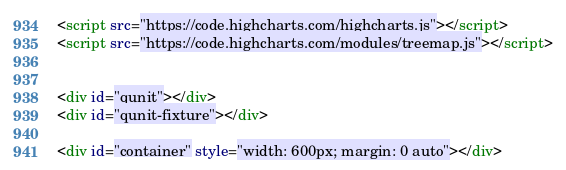<code> <loc_0><loc_0><loc_500><loc_500><_HTML_><script src="https://code.highcharts.com/highcharts.js"></script>
<script src="https://code.highcharts.com/modules/treemap.js"></script>


<div id="qunit"></div>
<div id="qunit-fixture"></div>

<div id="container" style="width: 600px; margin: 0 auto"></div></code> 